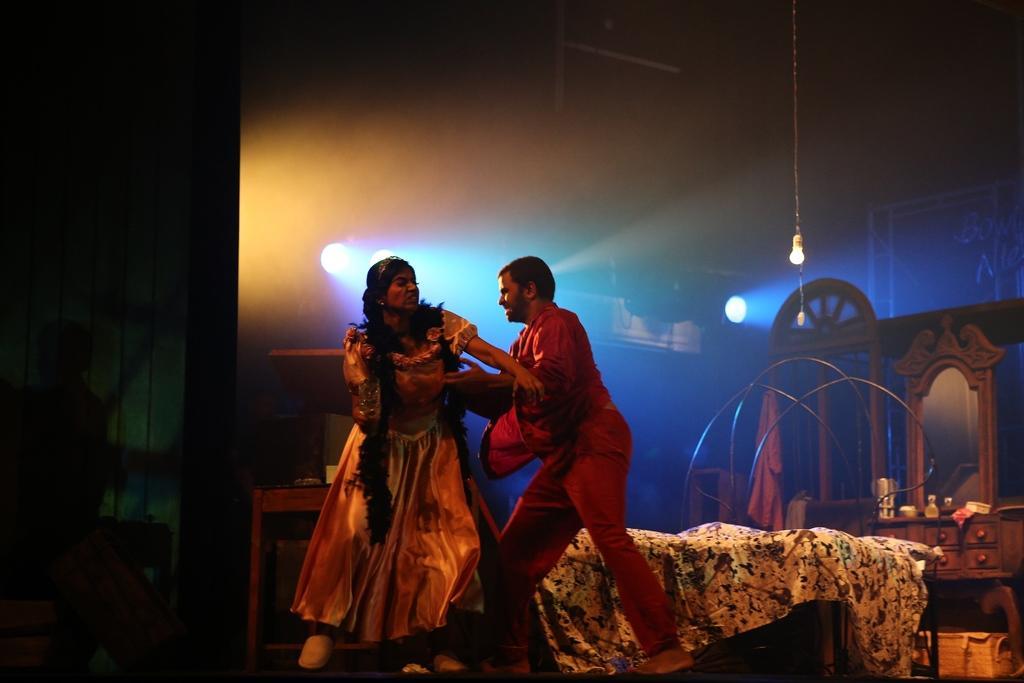Could you give a brief overview of what you see in this image? In the center of the image we can see two people performing in the play. At the bottom there is a bed and we can see a mirror. There are things placed on the table. On the left there is a table. In the background there are lights. 